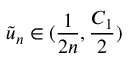<formula> <loc_0><loc_0><loc_500><loc_500>\tilde { u } _ { n } \in ( \frac { 1 } { 2 n } , \frac { C _ { 1 } } { 2 } )</formula> 